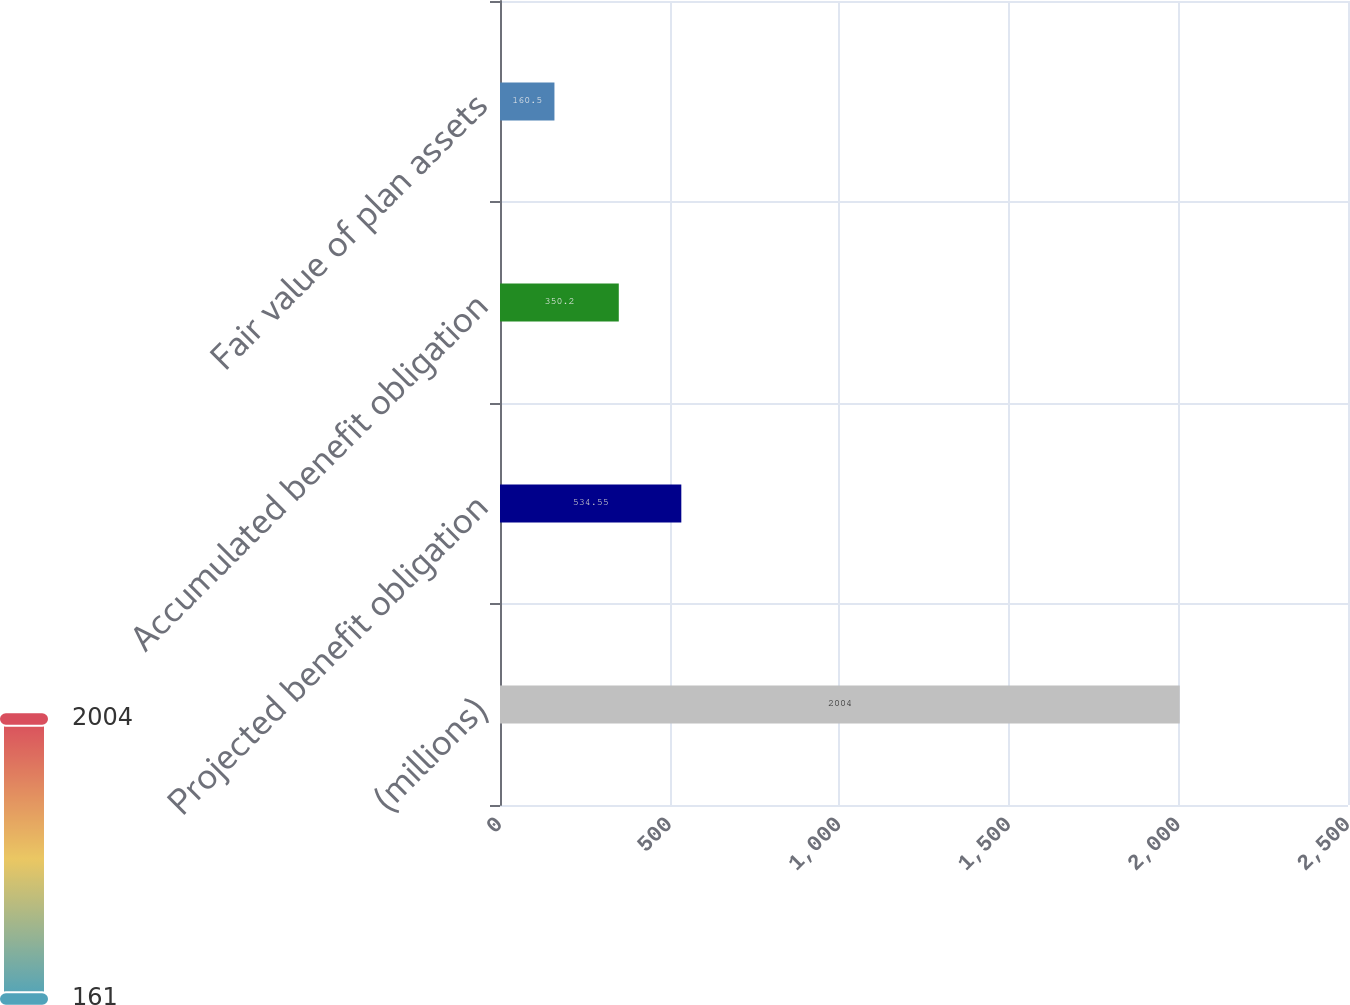Convert chart to OTSL. <chart><loc_0><loc_0><loc_500><loc_500><bar_chart><fcel>(millions)<fcel>Projected benefit obligation<fcel>Accumulated benefit obligation<fcel>Fair value of plan assets<nl><fcel>2004<fcel>534.55<fcel>350.2<fcel>160.5<nl></chart> 